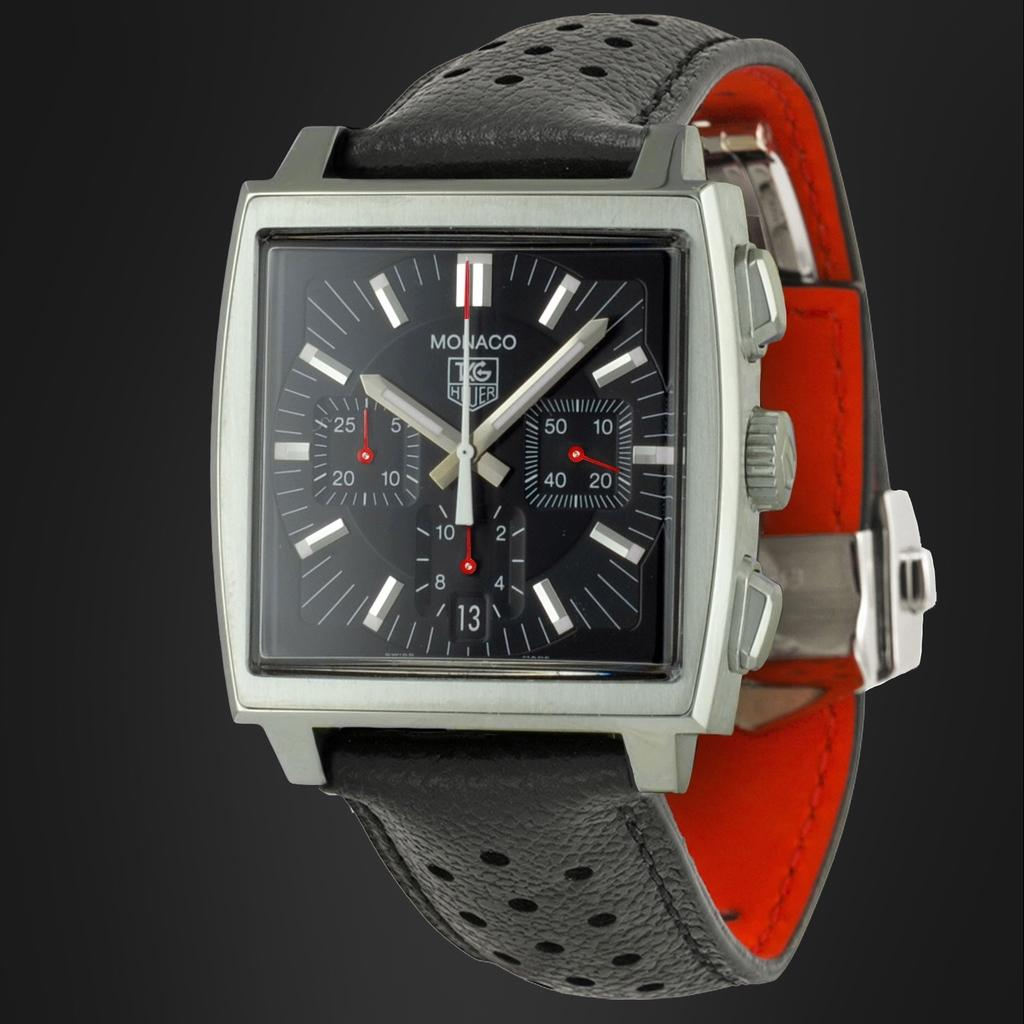<image>
Offer a succinct explanation of the picture presented. A Monaco watch in black and red shows the time. 